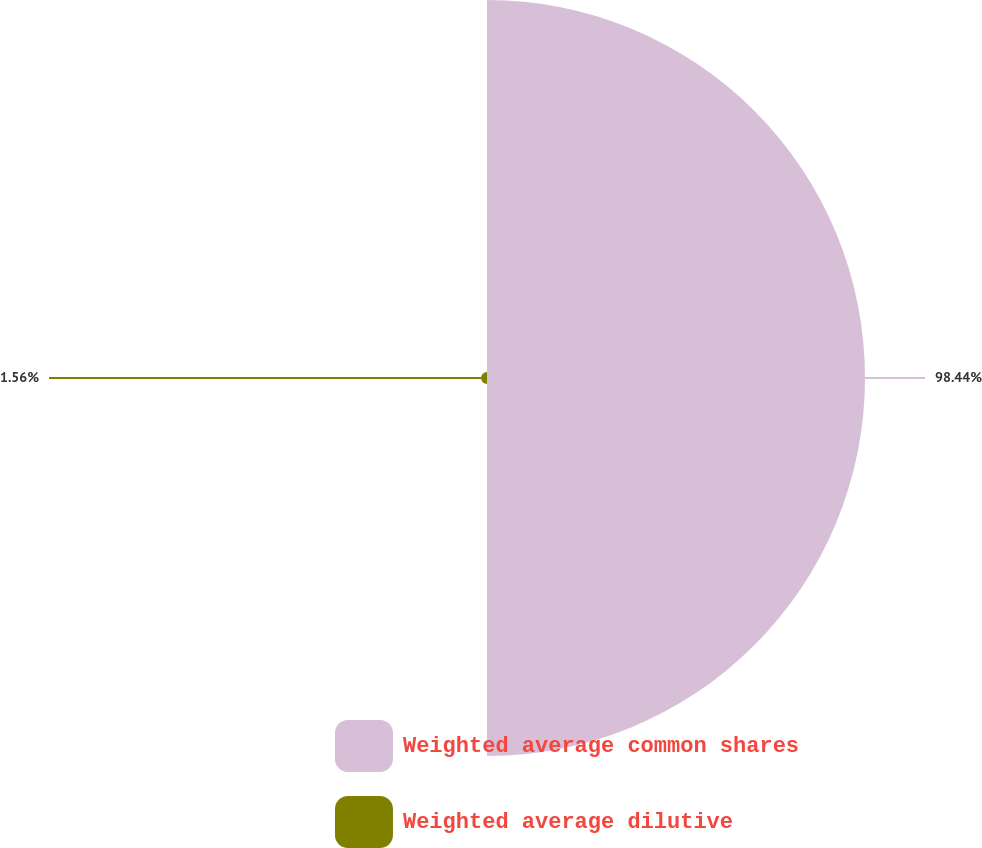Convert chart. <chart><loc_0><loc_0><loc_500><loc_500><pie_chart><fcel>Weighted average common shares<fcel>Weighted average dilutive<nl><fcel>98.44%<fcel>1.56%<nl></chart> 